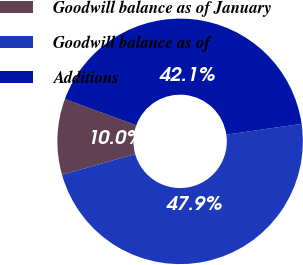Convert chart to OTSL. <chart><loc_0><loc_0><loc_500><loc_500><pie_chart><fcel>Goodwill balance as of January<fcel>Goodwill balance as of<fcel>Additions<nl><fcel>9.99%<fcel>47.89%<fcel>42.12%<nl></chart> 